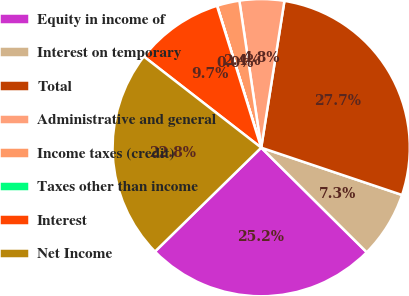Convert chart. <chart><loc_0><loc_0><loc_500><loc_500><pie_chart><fcel>Equity in income of<fcel>Interest on temporary<fcel>Total<fcel>Administrative and general<fcel>Income taxes (credit)<fcel>Taxes other than income<fcel>Interest<fcel>Net Income<nl><fcel>25.25%<fcel>7.27%<fcel>27.66%<fcel>4.85%<fcel>2.44%<fcel>0.02%<fcel>9.68%<fcel>22.83%<nl></chart> 